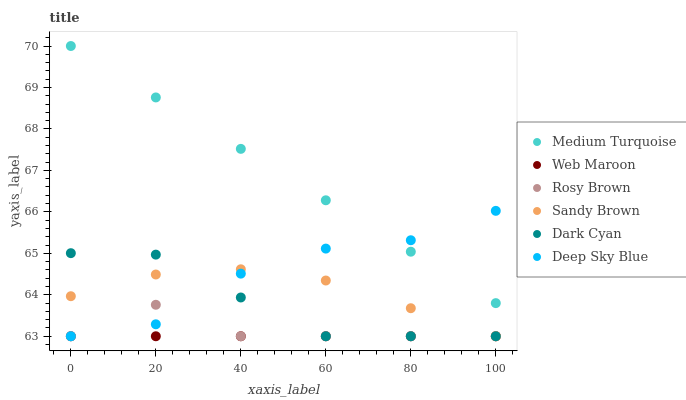Does Web Maroon have the minimum area under the curve?
Answer yes or no. Yes. Does Medium Turquoise have the maximum area under the curve?
Answer yes or no. Yes. Does Rosy Brown have the minimum area under the curve?
Answer yes or no. No. Does Rosy Brown have the maximum area under the curve?
Answer yes or no. No. Is Web Maroon the smoothest?
Answer yes or no. Yes. Is Deep Sky Blue the roughest?
Answer yes or no. Yes. Is Rosy Brown the smoothest?
Answer yes or no. No. Is Rosy Brown the roughest?
Answer yes or no. No. Does Rosy Brown have the lowest value?
Answer yes or no. Yes. Does Medium Turquoise have the highest value?
Answer yes or no. Yes. Does Rosy Brown have the highest value?
Answer yes or no. No. Is Rosy Brown less than Medium Turquoise?
Answer yes or no. Yes. Is Medium Turquoise greater than Rosy Brown?
Answer yes or no. Yes. Does Web Maroon intersect Sandy Brown?
Answer yes or no. Yes. Is Web Maroon less than Sandy Brown?
Answer yes or no. No. Is Web Maroon greater than Sandy Brown?
Answer yes or no. No. Does Rosy Brown intersect Medium Turquoise?
Answer yes or no. No. 